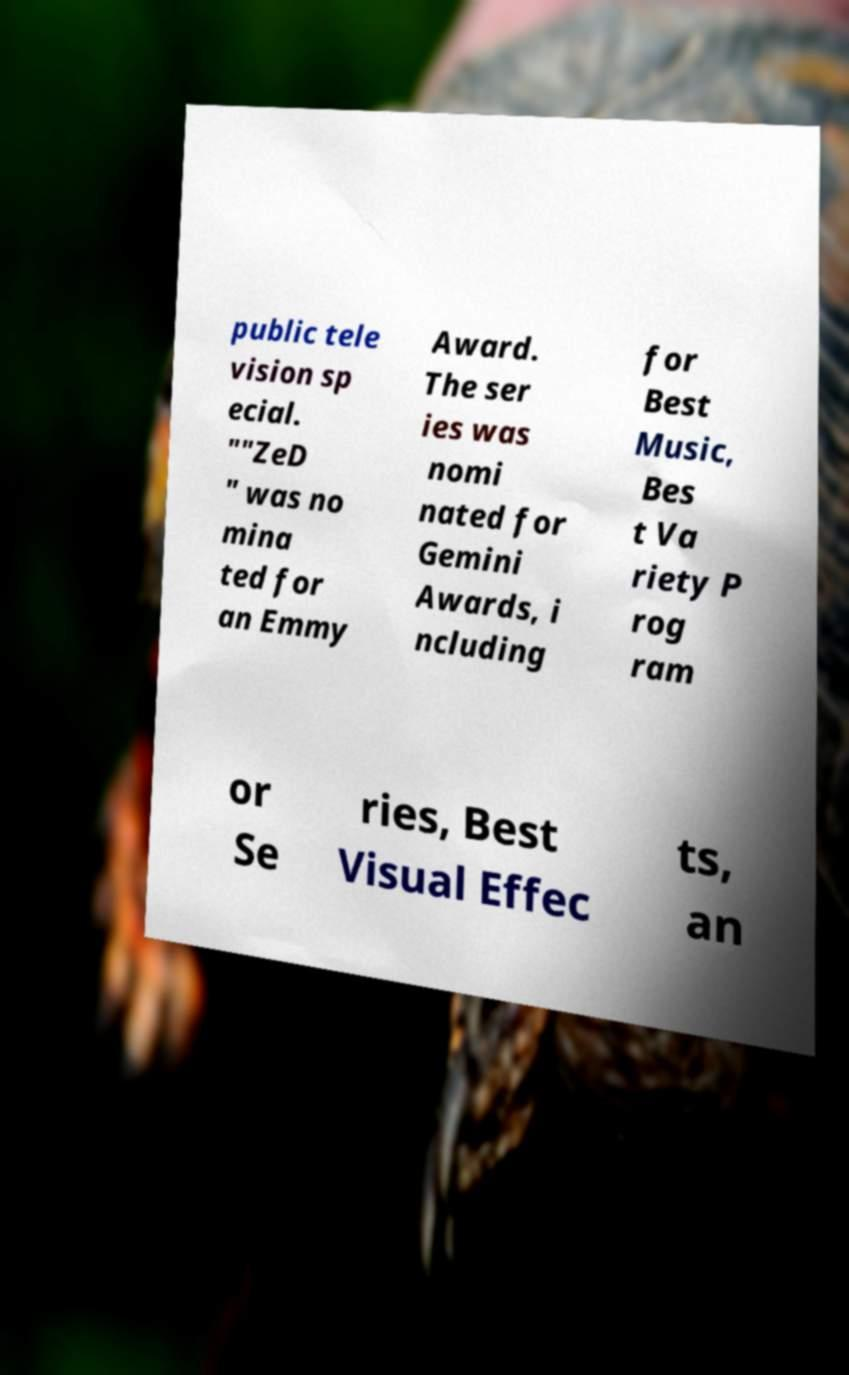What messages or text are displayed in this image? I need them in a readable, typed format. public tele vision sp ecial. ""ZeD " was no mina ted for an Emmy Award. The ser ies was nomi nated for Gemini Awards, i ncluding for Best Music, Bes t Va riety P rog ram or Se ries, Best Visual Effec ts, an 